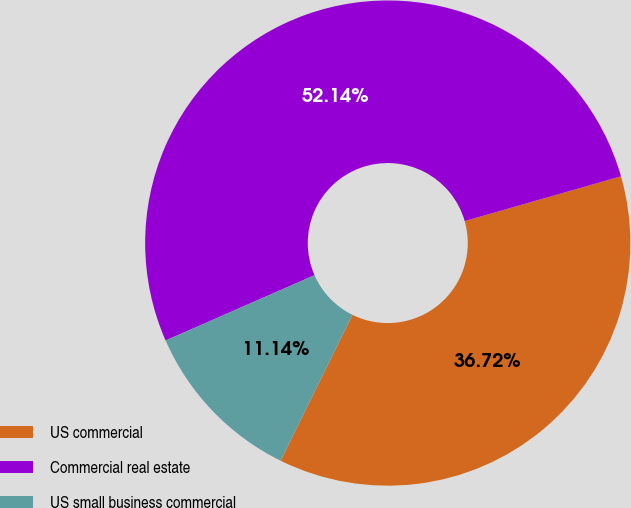<chart> <loc_0><loc_0><loc_500><loc_500><pie_chart><fcel>US commercial<fcel>Commercial real estate<fcel>US small business commercial<nl><fcel>36.72%<fcel>52.15%<fcel>11.14%<nl></chart> 